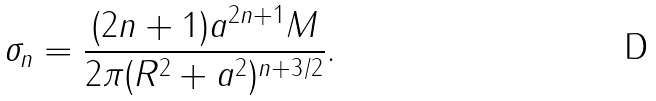<formula> <loc_0><loc_0><loc_500><loc_500>\sigma _ { n } = \frac { ( 2 n + 1 ) a ^ { 2 n + 1 } M } { 2 \pi ( R ^ { 2 } + a ^ { 2 } ) ^ { n + 3 / 2 } } .</formula> 